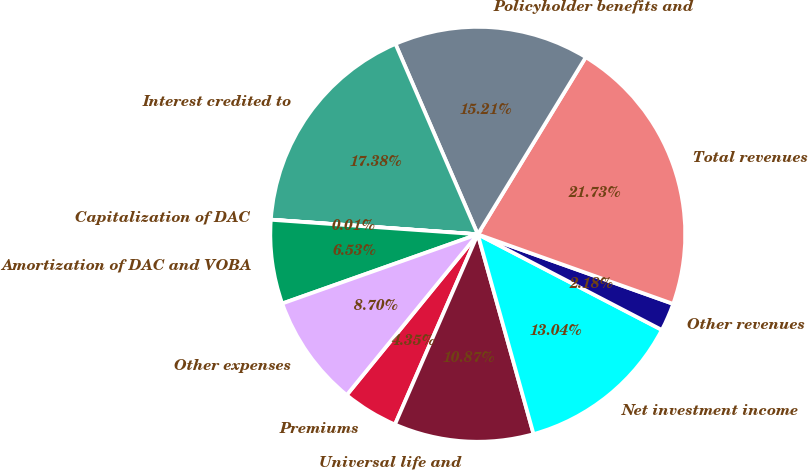Convert chart. <chart><loc_0><loc_0><loc_500><loc_500><pie_chart><fcel>Premiums<fcel>Universal life and<fcel>Net investment income<fcel>Other revenues<fcel>Total revenues<fcel>Policyholder benefits and<fcel>Interest credited to<fcel>Capitalization of DAC<fcel>Amortization of DAC and VOBA<fcel>Other expenses<nl><fcel>4.35%<fcel>10.87%<fcel>13.04%<fcel>2.18%<fcel>21.73%<fcel>15.21%<fcel>17.38%<fcel>0.01%<fcel>6.53%<fcel>8.7%<nl></chart> 